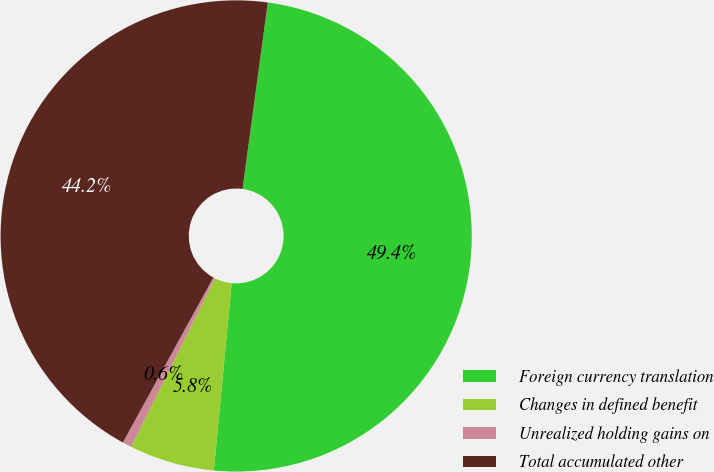Convert chart. <chart><loc_0><loc_0><loc_500><loc_500><pie_chart><fcel>Foreign currency translation<fcel>Changes in defined benefit<fcel>Unrealized holding gains on<fcel>Total accumulated other<nl><fcel>49.37%<fcel>5.84%<fcel>0.63%<fcel>44.16%<nl></chart> 